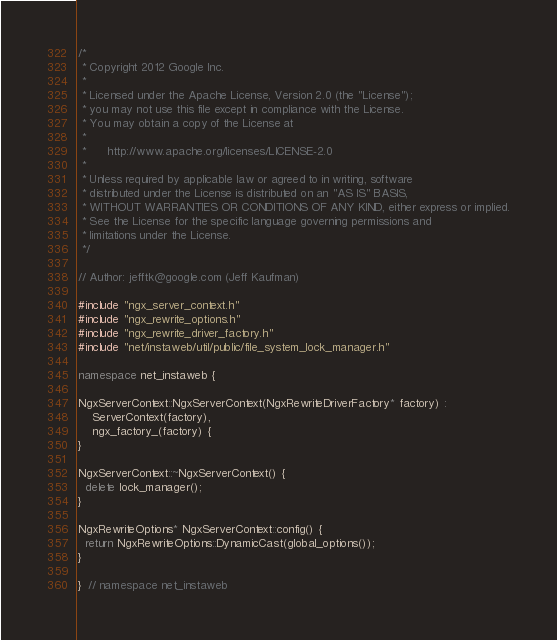<code> <loc_0><loc_0><loc_500><loc_500><_C++_>/*
 * Copyright 2012 Google Inc.
 *
 * Licensed under the Apache License, Version 2.0 (the "License");
 * you may not use this file except in compliance with the License.
 * You may obtain a copy of the License at
 *
 *      http://www.apache.org/licenses/LICENSE-2.0
 *
 * Unless required by applicable law or agreed to in writing, software
 * distributed under the License is distributed on an "AS IS" BASIS,
 * WITHOUT WARRANTIES OR CONDITIONS OF ANY KIND, either express or implied.
 * See the License for the specific language governing permissions and
 * limitations under the License.
 */

// Author: jefftk@google.com (Jeff Kaufman)

#include "ngx_server_context.h"
#include "ngx_rewrite_options.h"
#include "ngx_rewrite_driver_factory.h"
#include "net/instaweb/util/public/file_system_lock_manager.h"

namespace net_instaweb {

NgxServerContext::NgxServerContext(NgxRewriteDriverFactory* factory) :
    ServerContext(factory),
    ngx_factory_(factory) {
}

NgxServerContext::~NgxServerContext() {
  delete lock_manager();
}

NgxRewriteOptions* NgxServerContext::config() {
  return NgxRewriteOptions::DynamicCast(global_options());
}

}  // namespace net_instaweb
</code> 